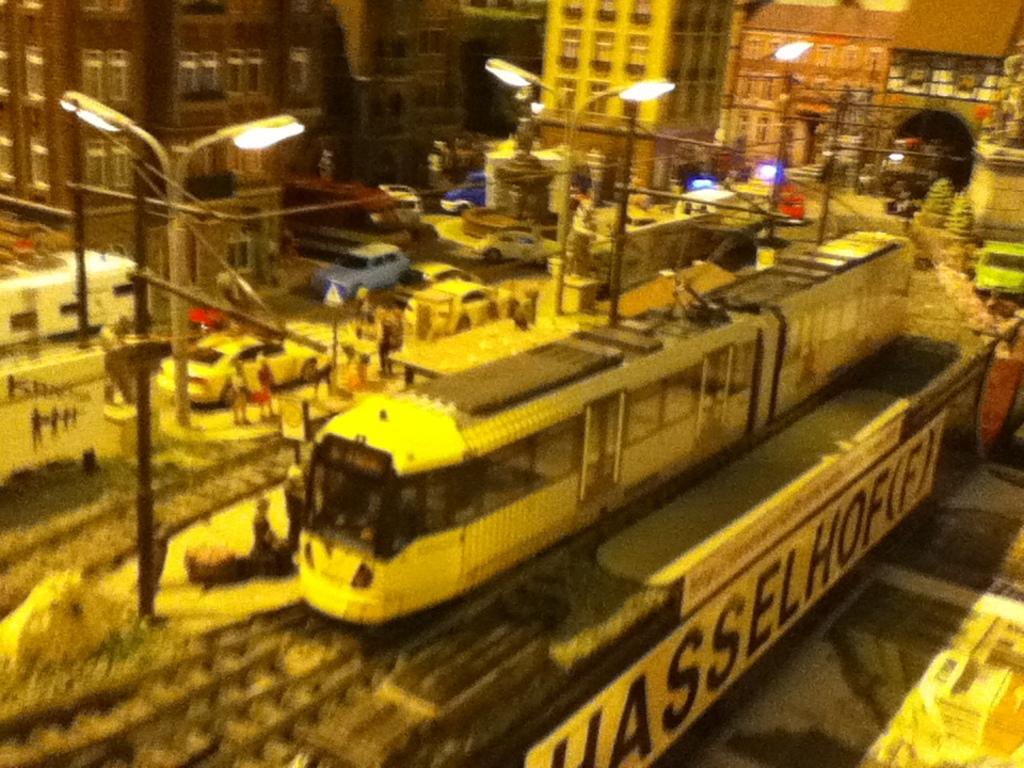What is written on the whit ebanner?
Offer a very short reply. Hasselhof(f). Which letters are repeated twice in the white banner?
Provide a short and direct response. S. 